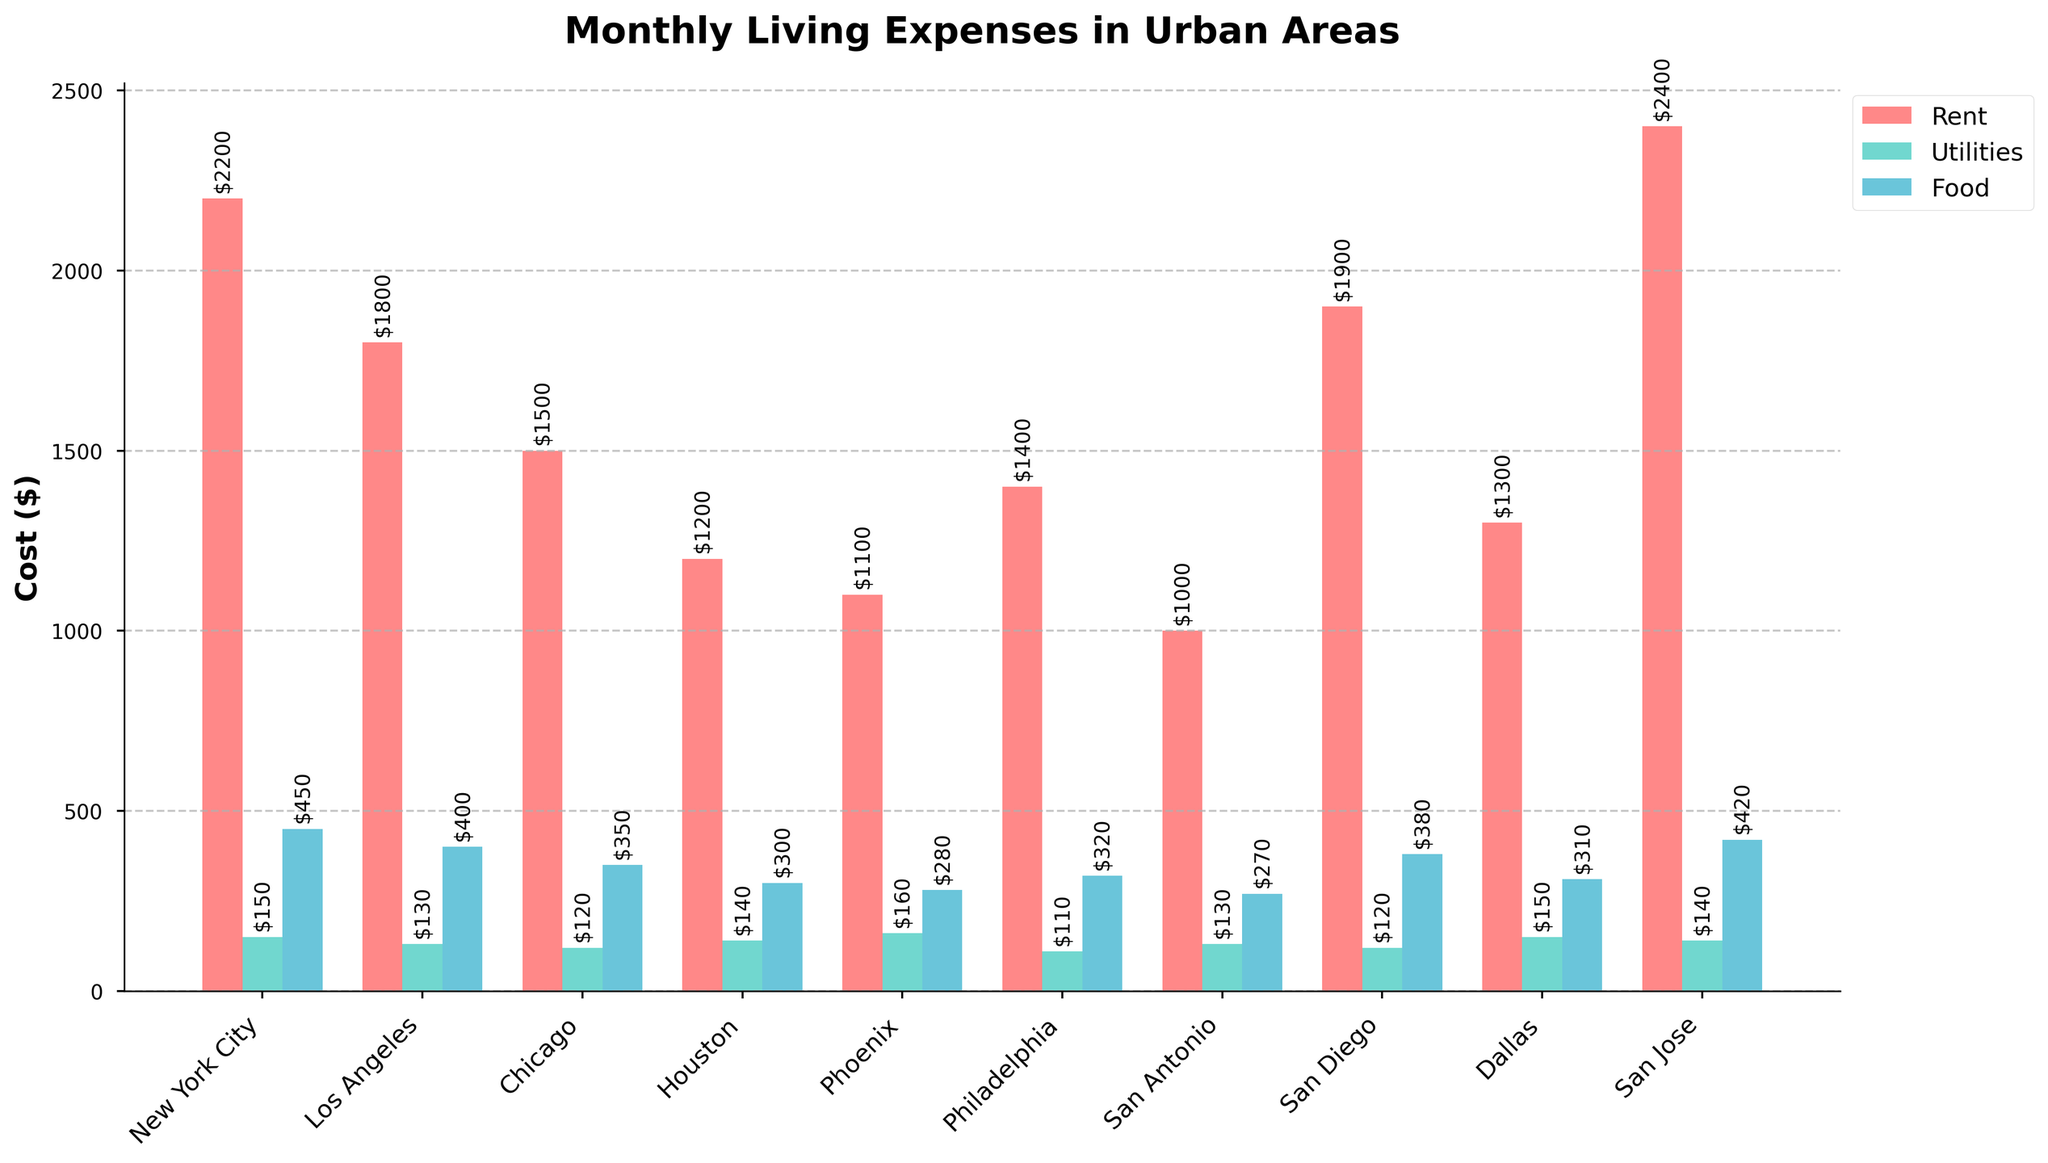Which city has the highest rent cost? Look for the tallest red bar representing rent cost across all cities.
Answer: San Jose What is the difference in monthly rent between New York City and Houston? Subtract the rent value of Houston from New York City's rent value. $2200 - $1200 = $1000
Answer: $1000 In which city are the utility costs the lowest, and what is the value? Identify the shortest green bar, which represents utilities cost.
Answer: Philadelphia, $110 What is the combined cost of rent, utilities, and food in Chicago? Add the values of rent, utilities, and food for Chicago. $1500 + $120 + $350 = $1970
Answer: $1970 Which city has the highest food cost and what is this value? Locate the tallest blue bar representing food costs across all cities.
Answer: New York City, $450 How much more expensive is renting in Los Angeles compared to Phoenix? Subtract the rent value of Phoenix from Los Angeles' rent value. $1800 - $1100 = $700
Answer: $700 Which city has the lowest total living expenses (sum of rent, utilities, and food)? Calculate the total living expenses for each city and compare them to find the lowest one.
Answer: San Antonio, $1400 What is the average cost of utilities across all the cities? Sum the utilities values of all cities and divide by the number of cities. ($150 + $130 + $120 + $140 + $160 + $110 + $130 + $120 + $150 + $140) / 10 = $135
Answer: $135 Compare the rent costs of Dallas and San Antonio: which is higher, and by how much? Identify the rent costs of Dallas ($1300) and San Antonio ($1000), then subtract San Antonio's rent from Dallas'. $1300 - $1000 = $300
Answer: Dallas, $300 Which city has total living expenses exactly equal to the sum of utilities in Houston and food cost in New York City? Calculate the sum of Houston's utilities and New York City's food cost ($140 + $450 = $590). Find a city whose total living expenses equals $590, which isn't a match in this case.
Answer: No city matches 